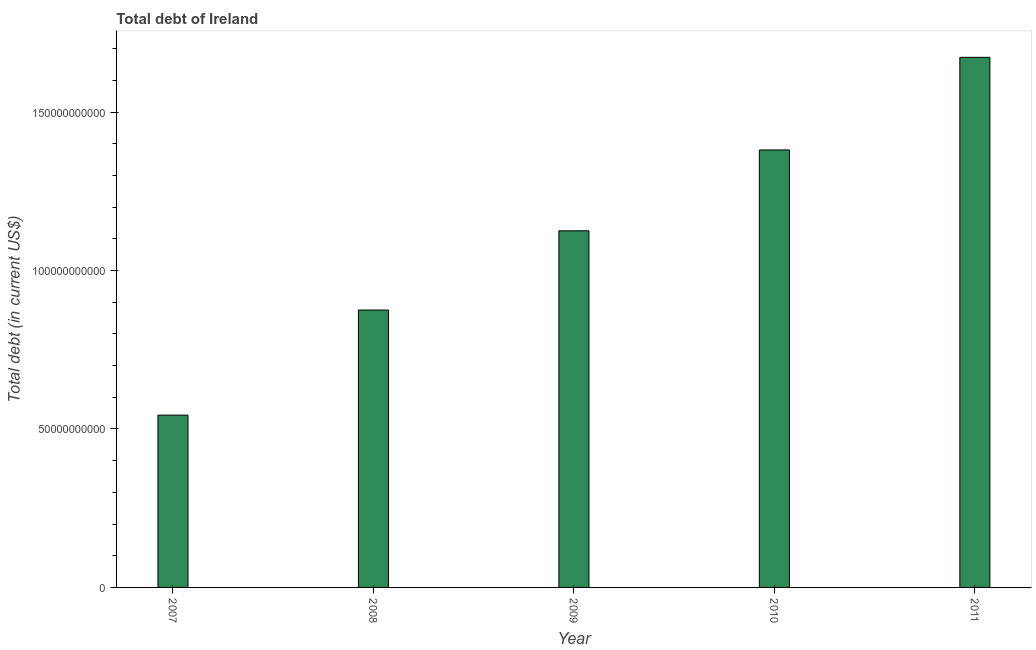Does the graph contain any zero values?
Keep it short and to the point. No. Does the graph contain grids?
Offer a very short reply. No. What is the title of the graph?
Provide a short and direct response. Total debt of Ireland. What is the label or title of the Y-axis?
Give a very brief answer. Total debt (in current US$). What is the total debt in 2010?
Your answer should be compact. 1.38e+11. Across all years, what is the maximum total debt?
Give a very brief answer. 1.67e+11. Across all years, what is the minimum total debt?
Your answer should be very brief. 5.44e+1. In which year was the total debt maximum?
Offer a terse response. 2011. In which year was the total debt minimum?
Offer a very short reply. 2007. What is the sum of the total debt?
Ensure brevity in your answer.  5.60e+11. What is the difference between the total debt in 2008 and 2011?
Provide a succinct answer. -7.97e+1. What is the average total debt per year?
Your answer should be compact. 1.12e+11. What is the median total debt?
Your response must be concise. 1.13e+11. What is the ratio of the total debt in 2007 to that in 2009?
Keep it short and to the point. 0.48. Is the total debt in 2009 less than that in 2011?
Offer a very short reply. Yes. Is the difference between the total debt in 2007 and 2008 greater than the difference between any two years?
Your response must be concise. No. What is the difference between the highest and the second highest total debt?
Ensure brevity in your answer.  2.92e+1. What is the difference between the highest and the lowest total debt?
Give a very brief answer. 1.13e+11. How many bars are there?
Offer a very short reply. 5. What is the difference between two consecutive major ticks on the Y-axis?
Provide a short and direct response. 5.00e+1. Are the values on the major ticks of Y-axis written in scientific E-notation?
Ensure brevity in your answer.  No. What is the Total debt (in current US$) in 2007?
Offer a very short reply. 5.44e+1. What is the Total debt (in current US$) in 2008?
Provide a short and direct response. 8.75e+1. What is the Total debt (in current US$) in 2009?
Your response must be concise. 1.13e+11. What is the Total debt (in current US$) in 2010?
Keep it short and to the point. 1.38e+11. What is the Total debt (in current US$) in 2011?
Provide a short and direct response. 1.67e+11. What is the difference between the Total debt (in current US$) in 2007 and 2008?
Give a very brief answer. -3.32e+1. What is the difference between the Total debt (in current US$) in 2007 and 2009?
Offer a very short reply. -5.82e+1. What is the difference between the Total debt (in current US$) in 2007 and 2010?
Make the answer very short. -8.37e+1. What is the difference between the Total debt (in current US$) in 2007 and 2011?
Ensure brevity in your answer.  -1.13e+11. What is the difference between the Total debt (in current US$) in 2008 and 2009?
Keep it short and to the point. -2.50e+1. What is the difference between the Total debt (in current US$) in 2008 and 2010?
Your answer should be very brief. -5.05e+1. What is the difference between the Total debt (in current US$) in 2008 and 2011?
Keep it short and to the point. -7.97e+1. What is the difference between the Total debt (in current US$) in 2009 and 2010?
Provide a succinct answer. -2.55e+1. What is the difference between the Total debt (in current US$) in 2009 and 2011?
Your answer should be very brief. -5.47e+1. What is the difference between the Total debt (in current US$) in 2010 and 2011?
Give a very brief answer. -2.92e+1. What is the ratio of the Total debt (in current US$) in 2007 to that in 2008?
Give a very brief answer. 0.62. What is the ratio of the Total debt (in current US$) in 2007 to that in 2009?
Provide a short and direct response. 0.48. What is the ratio of the Total debt (in current US$) in 2007 to that in 2010?
Offer a very short reply. 0.39. What is the ratio of the Total debt (in current US$) in 2007 to that in 2011?
Ensure brevity in your answer.  0.33. What is the ratio of the Total debt (in current US$) in 2008 to that in 2009?
Make the answer very short. 0.78. What is the ratio of the Total debt (in current US$) in 2008 to that in 2010?
Offer a terse response. 0.63. What is the ratio of the Total debt (in current US$) in 2008 to that in 2011?
Your answer should be very brief. 0.52. What is the ratio of the Total debt (in current US$) in 2009 to that in 2010?
Give a very brief answer. 0.81. What is the ratio of the Total debt (in current US$) in 2009 to that in 2011?
Ensure brevity in your answer.  0.67. What is the ratio of the Total debt (in current US$) in 2010 to that in 2011?
Offer a very short reply. 0.82. 